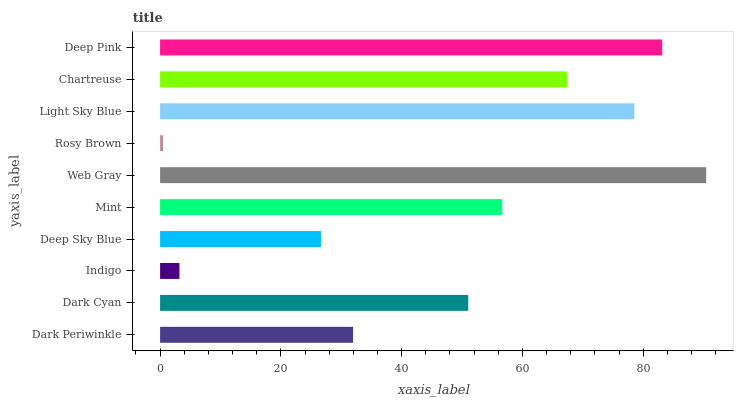Is Rosy Brown the minimum?
Answer yes or no. Yes. Is Web Gray the maximum?
Answer yes or no. Yes. Is Dark Cyan the minimum?
Answer yes or no. No. Is Dark Cyan the maximum?
Answer yes or no. No. Is Dark Cyan greater than Dark Periwinkle?
Answer yes or no. Yes. Is Dark Periwinkle less than Dark Cyan?
Answer yes or no. Yes. Is Dark Periwinkle greater than Dark Cyan?
Answer yes or no. No. Is Dark Cyan less than Dark Periwinkle?
Answer yes or no. No. Is Mint the high median?
Answer yes or no. Yes. Is Dark Cyan the low median?
Answer yes or no. Yes. Is Chartreuse the high median?
Answer yes or no. No. Is Deep Sky Blue the low median?
Answer yes or no. No. 